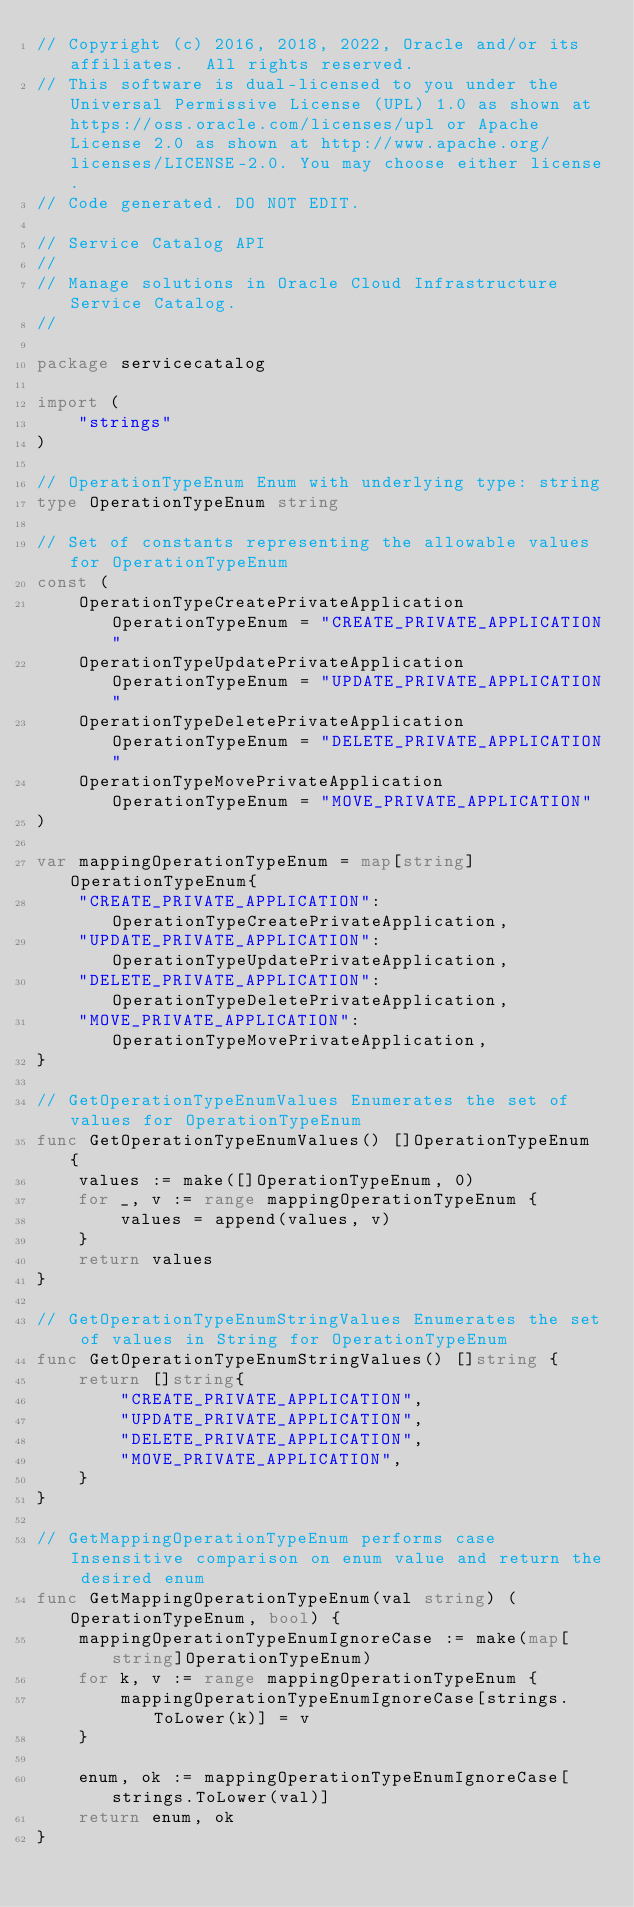Convert code to text. <code><loc_0><loc_0><loc_500><loc_500><_Go_>// Copyright (c) 2016, 2018, 2022, Oracle and/or its affiliates.  All rights reserved.
// This software is dual-licensed to you under the Universal Permissive License (UPL) 1.0 as shown at https://oss.oracle.com/licenses/upl or Apache License 2.0 as shown at http://www.apache.org/licenses/LICENSE-2.0. You may choose either license.
// Code generated. DO NOT EDIT.

// Service Catalog API
//
// Manage solutions in Oracle Cloud Infrastructure Service Catalog.
//

package servicecatalog

import (
	"strings"
)

// OperationTypeEnum Enum with underlying type: string
type OperationTypeEnum string

// Set of constants representing the allowable values for OperationTypeEnum
const (
	OperationTypeCreatePrivateApplication OperationTypeEnum = "CREATE_PRIVATE_APPLICATION"
	OperationTypeUpdatePrivateApplication OperationTypeEnum = "UPDATE_PRIVATE_APPLICATION"
	OperationTypeDeletePrivateApplication OperationTypeEnum = "DELETE_PRIVATE_APPLICATION"
	OperationTypeMovePrivateApplication   OperationTypeEnum = "MOVE_PRIVATE_APPLICATION"
)

var mappingOperationTypeEnum = map[string]OperationTypeEnum{
	"CREATE_PRIVATE_APPLICATION": OperationTypeCreatePrivateApplication,
	"UPDATE_PRIVATE_APPLICATION": OperationTypeUpdatePrivateApplication,
	"DELETE_PRIVATE_APPLICATION": OperationTypeDeletePrivateApplication,
	"MOVE_PRIVATE_APPLICATION":   OperationTypeMovePrivateApplication,
}

// GetOperationTypeEnumValues Enumerates the set of values for OperationTypeEnum
func GetOperationTypeEnumValues() []OperationTypeEnum {
	values := make([]OperationTypeEnum, 0)
	for _, v := range mappingOperationTypeEnum {
		values = append(values, v)
	}
	return values
}

// GetOperationTypeEnumStringValues Enumerates the set of values in String for OperationTypeEnum
func GetOperationTypeEnumStringValues() []string {
	return []string{
		"CREATE_PRIVATE_APPLICATION",
		"UPDATE_PRIVATE_APPLICATION",
		"DELETE_PRIVATE_APPLICATION",
		"MOVE_PRIVATE_APPLICATION",
	}
}

// GetMappingOperationTypeEnum performs case Insensitive comparison on enum value and return the desired enum
func GetMappingOperationTypeEnum(val string) (OperationTypeEnum, bool) {
	mappingOperationTypeEnumIgnoreCase := make(map[string]OperationTypeEnum)
	for k, v := range mappingOperationTypeEnum {
		mappingOperationTypeEnumIgnoreCase[strings.ToLower(k)] = v
	}

	enum, ok := mappingOperationTypeEnumIgnoreCase[strings.ToLower(val)]
	return enum, ok
}
</code> 